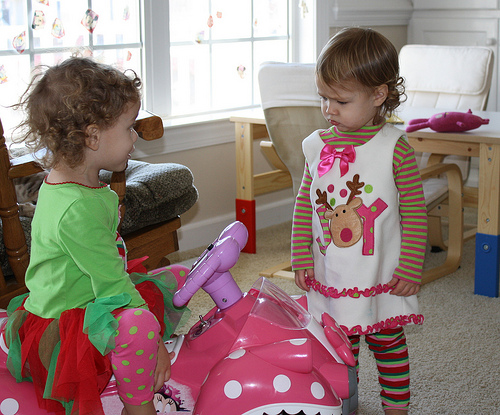<image>
Is there a toy car to the right of the kid? No. The toy car is not to the right of the kid. The horizontal positioning shows a different relationship. Is the green girl to the right of the white girl? No. The green girl is not to the right of the white girl. The horizontal positioning shows a different relationship. Where is the doll in relation to the girl? Is it in front of the girl? No. The doll is not in front of the girl. The spatial positioning shows a different relationship between these objects. 